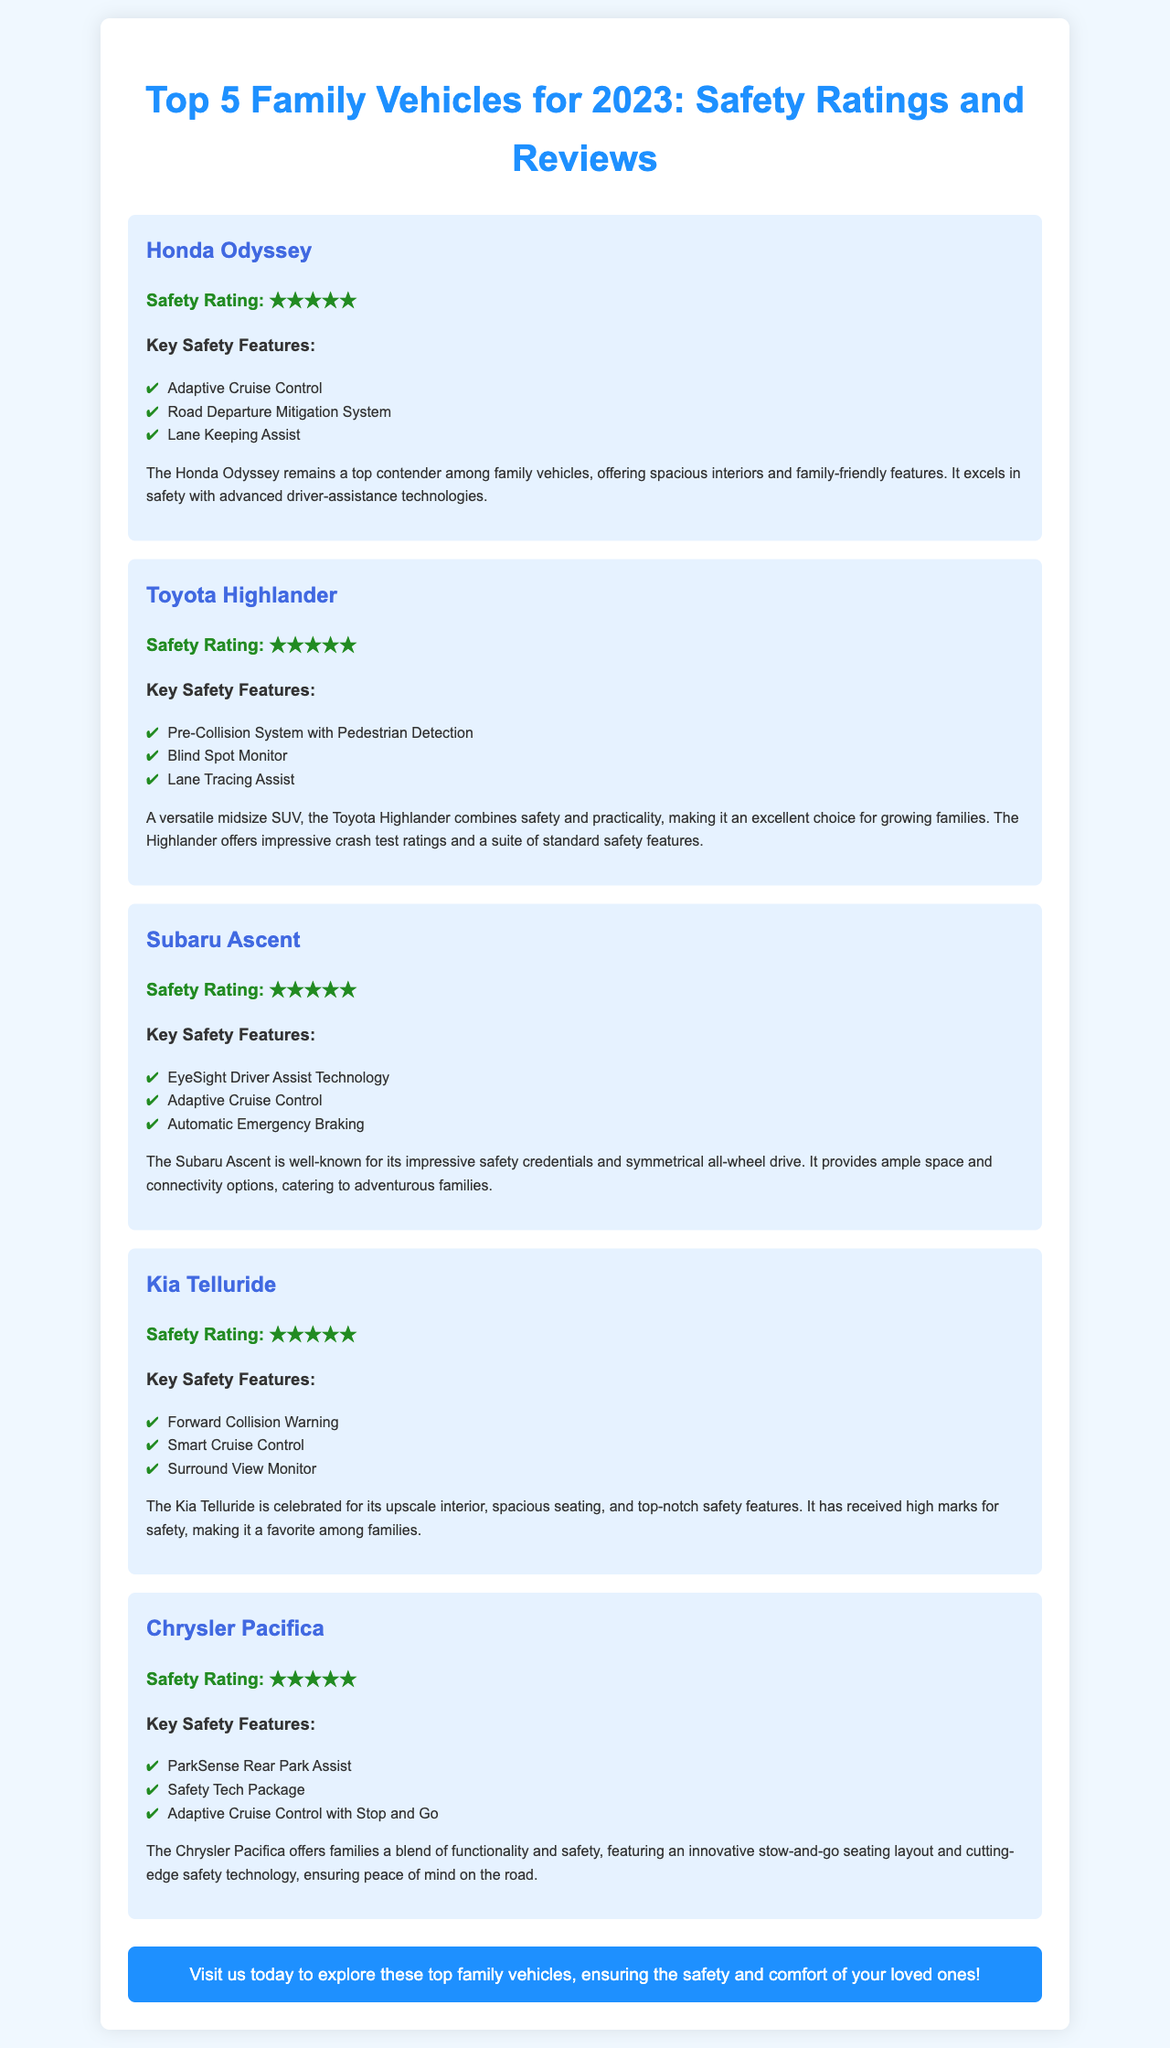what is the safety rating of the Honda Odyssey? The safety rating for the Honda Odyssey is stated in the document as ★★★★★.
Answer: ★★★★★ what are the key safety features of the Toyota Highlander? The document lists the key safety features of the Toyota Highlander.
Answer: Pre-Collision System with Pedestrian Detection, Blind Spot Monitor, Lane Tracing Assist how many family vehicles are highlighted in this brochure? The document specifically mentions five family vehicles.
Answer: 5 which vehicle is known for its EyeSight Driver Assist Technology? The Subaru Ascent is known for its EyeSight Driver Assist Technology according to the information provided.
Answer: Subaru Ascent what is a unique feature of the Chrysler Pacifica? The document mentions the innovative stow-and-go seating layout as a unique feature of the Chrysler Pacifica.
Answer: Stow-and-go seating layout which family vehicle offers a Surround View Monitor? The Kia Telluride offers a Surround View Monitor as one of its key safety features.
Answer: Kia Telluride how does the Honda Odyssey excel in safety? The document explains that the Honda Odyssey excels in safety due to its advanced driver-assistance technologies.
Answer: Advanced driver-assistance technologies what is the primary purpose of this brochure? The document's primary purpose is to inform readers about the top family vehicles for safety.
Answer: Inform about top family vehicles for safety 